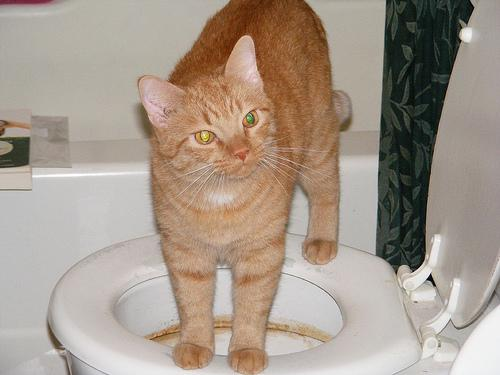Question: what color is the cat?
Choices:
A. Black.
B. Hairless.
C. White.
D. Orange.
Answer with the letter. Answer: D Question: who is shown?
Choices:
A. A rat.
B. A baby.
C. A dog.
D. A cat.
Answer with the letter. Answer: D Question: what is the cat doing?
Choices:
A. Standing on the toilet.
B. Sleeping.
C. Catching a rodent.
D. Eating.
Answer with the letter. Answer: A Question: how is the toilet seat cover?
Choices:
A. Down.
B. Broken.
C. There isn't one.
D. Up.
Answer with the letter. Answer: D Question: where is this scene?
Choices:
A. A bathroom.
B. A kitchen.
C. A living room.
D. A dining room.
Answer with the letter. Answer: A Question: what color are the cat's eyes?
Choices:
A. Black.
B. Blue.
C. Green and yellow.
D. Brown.
Answer with the letter. Answer: C 